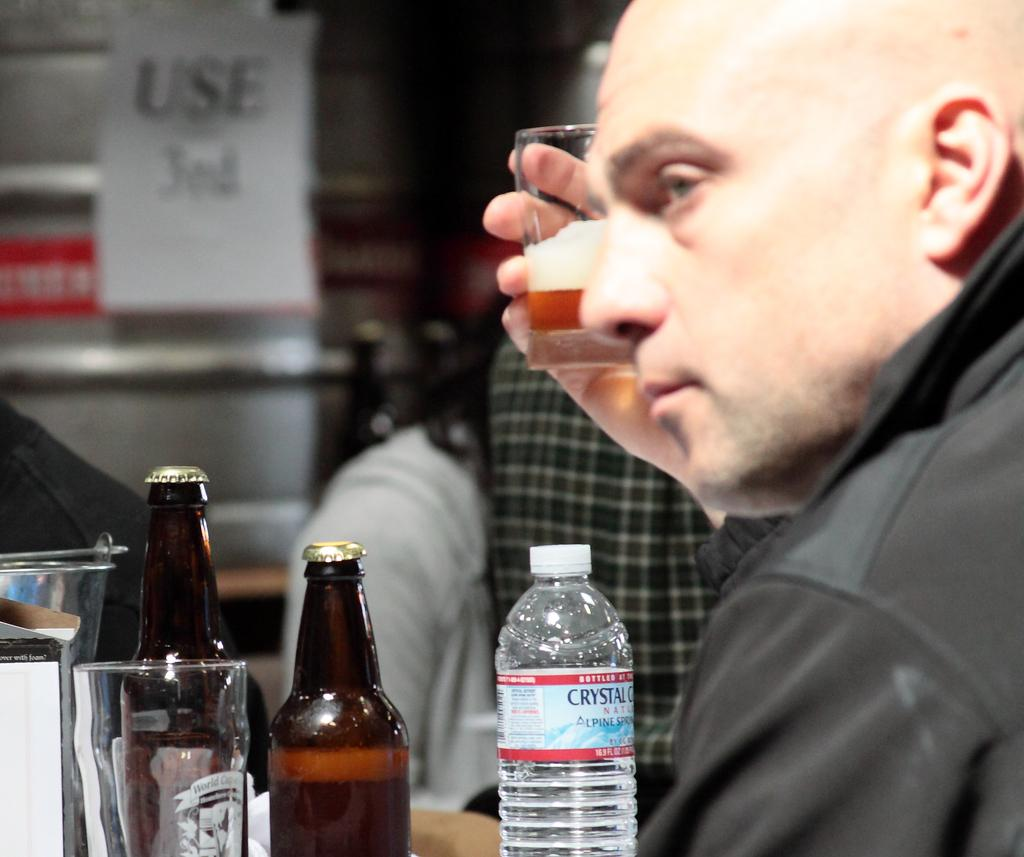Provide a one-sentence caption for the provided image. A man drinking beer also has a bottle of Crystal Geyser water in front of him. 